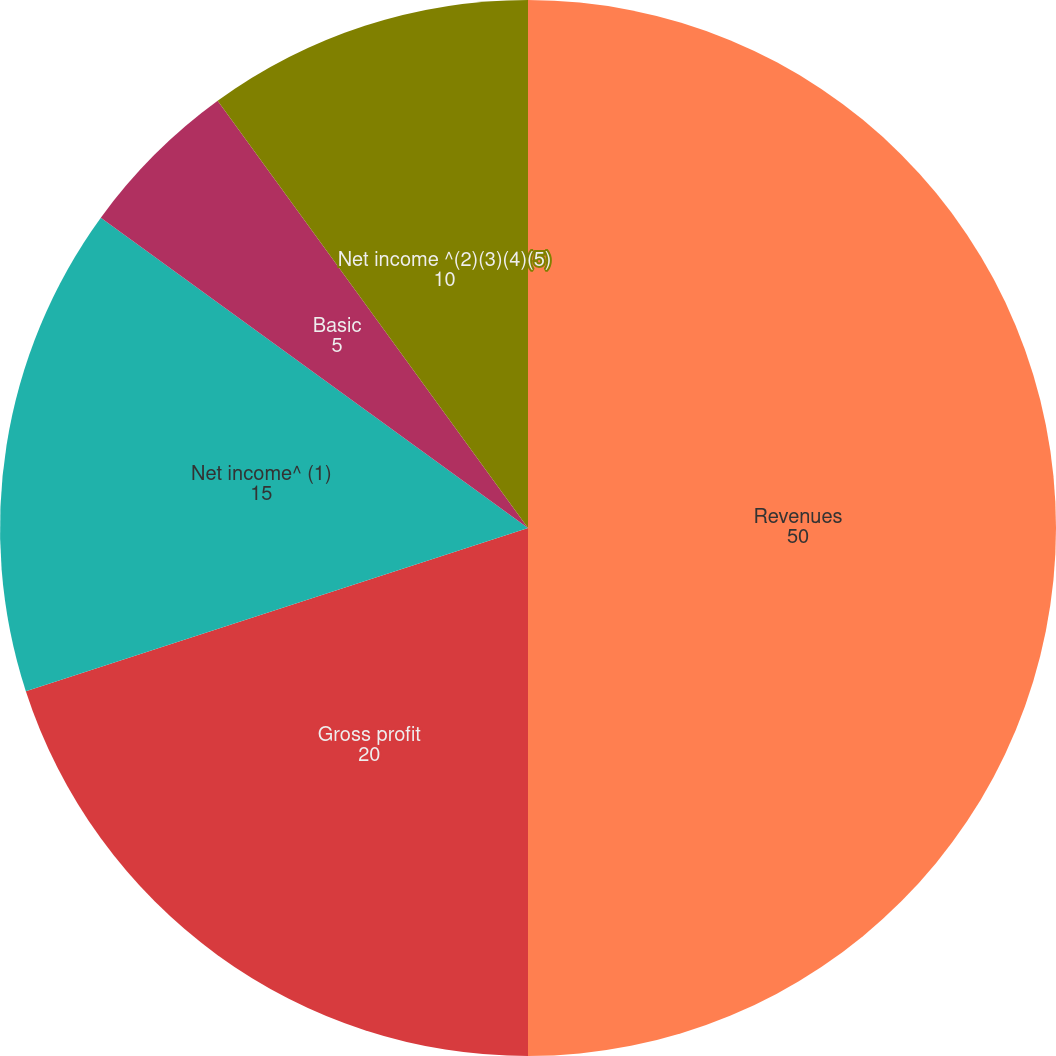<chart> <loc_0><loc_0><loc_500><loc_500><pie_chart><fcel>Revenues<fcel>Gross profit<fcel>Net income^ (1)<fcel>Diluted<fcel>Basic<fcel>Net income ^(2)(3)(4)(5)<nl><fcel>50.0%<fcel>20.0%<fcel>15.0%<fcel>0.0%<fcel>5.0%<fcel>10.0%<nl></chart> 